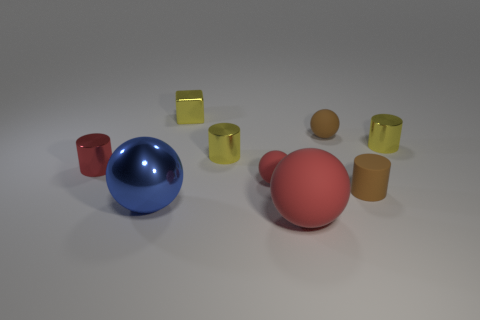Subtract all blue spheres. How many spheres are left? 3 Subtract all blue spheres. How many spheres are left? 3 Add 7 matte spheres. How many matte spheres are left? 10 Add 8 red rubber objects. How many red rubber objects exist? 10 Subtract 0 cyan spheres. How many objects are left? 9 Subtract all balls. How many objects are left? 5 Subtract 2 cylinders. How many cylinders are left? 2 Subtract all yellow spheres. Subtract all blue cubes. How many spheres are left? 4 Subtract all blue spheres. How many cyan cylinders are left? 0 Subtract all big red objects. Subtract all red cylinders. How many objects are left? 7 